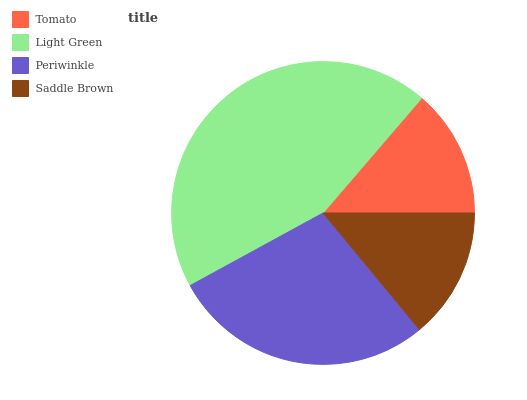Is Tomato the minimum?
Answer yes or no. Yes. Is Light Green the maximum?
Answer yes or no. Yes. Is Periwinkle the minimum?
Answer yes or no. No. Is Periwinkle the maximum?
Answer yes or no. No. Is Light Green greater than Periwinkle?
Answer yes or no. Yes. Is Periwinkle less than Light Green?
Answer yes or no. Yes. Is Periwinkle greater than Light Green?
Answer yes or no. No. Is Light Green less than Periwinkle?
Answer yes or no. No. Is Periwinkle the high median?
Answer yes or no. Yes. Is Saddle Brown the low median?
Answer yes or no. Yes. Is Saddle Brown the high median?
Answer yes or no. No. Is Tomato the low median?
Answer yes or no. No. 